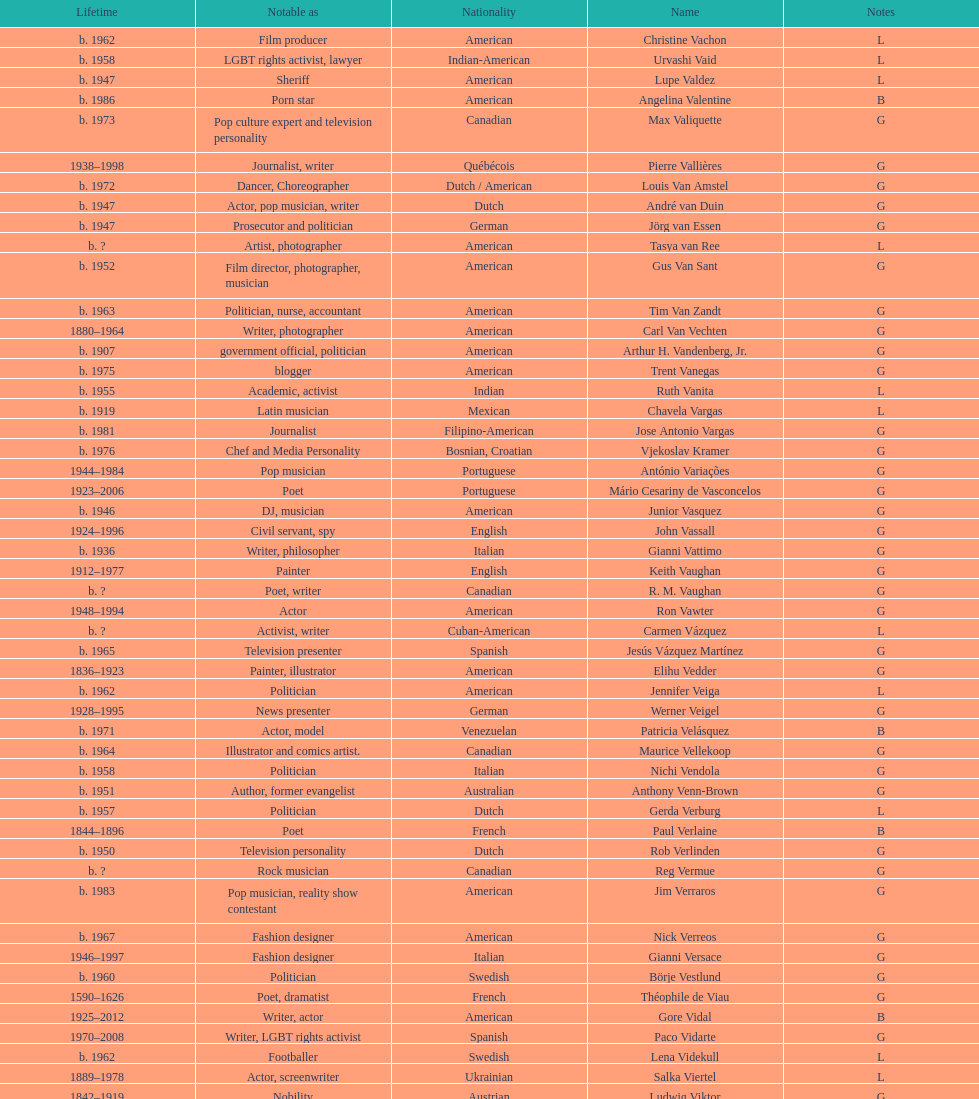How old was pierre vallieres before he died? 60. 